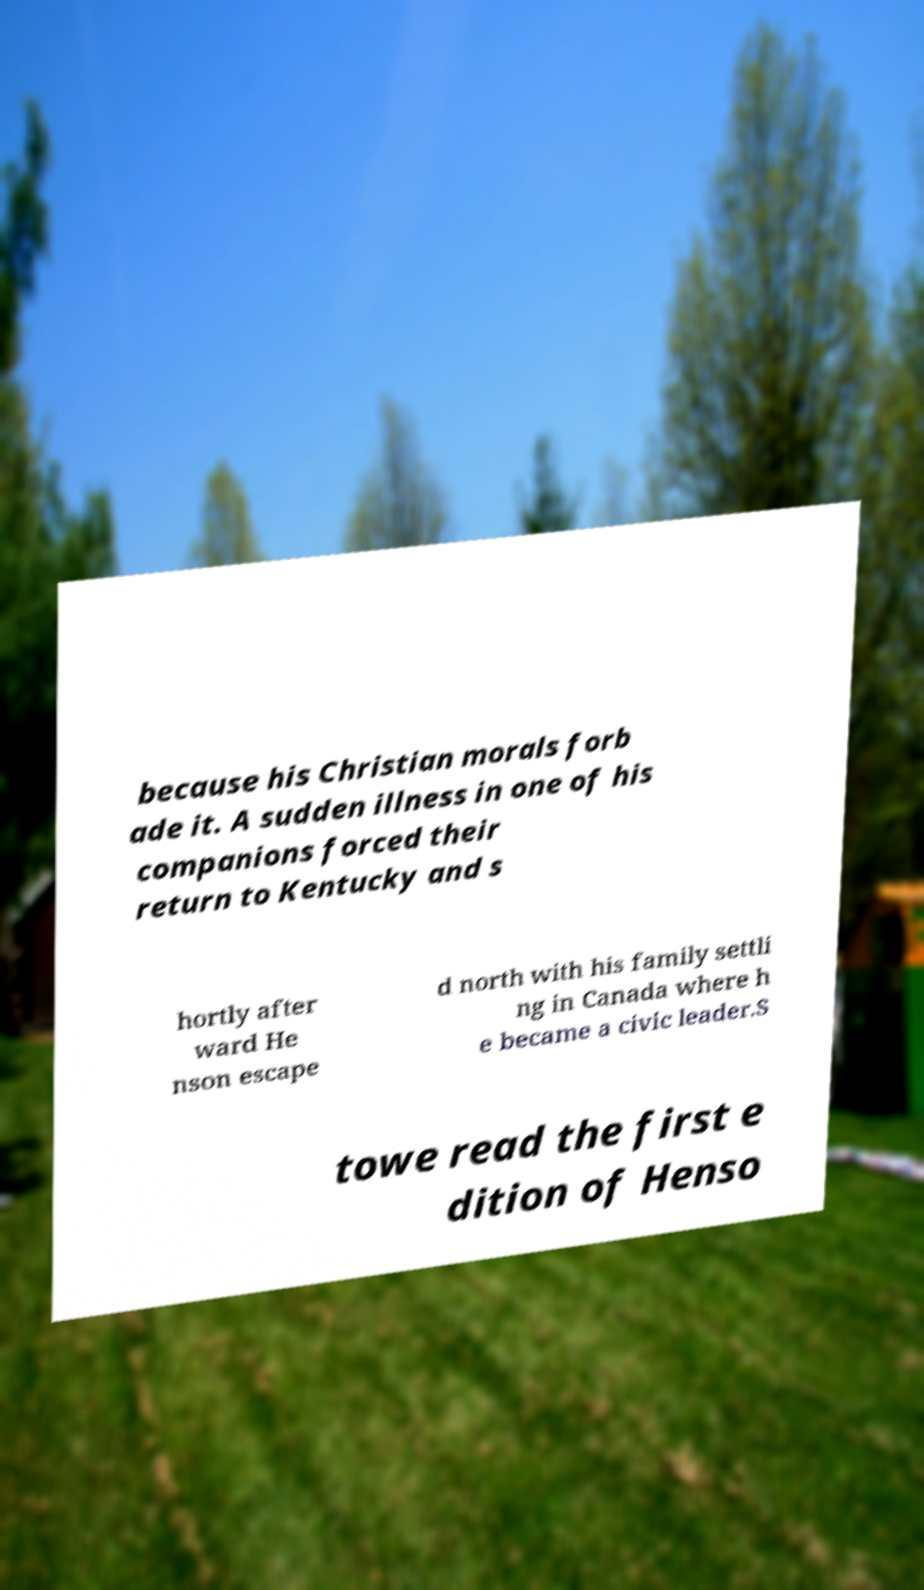Can you read and provide the text displayed in the image?This photo seems to have some interesting text. Can you extract and type it out for me? because his Christian morals forb ade it. A sudden illness in one of his companions forced their return to Kentucky and s hortly after ward He nson escape d north with his family settli ng in Canada where h e became a civic leader.S towe read the first e dition of Henso 